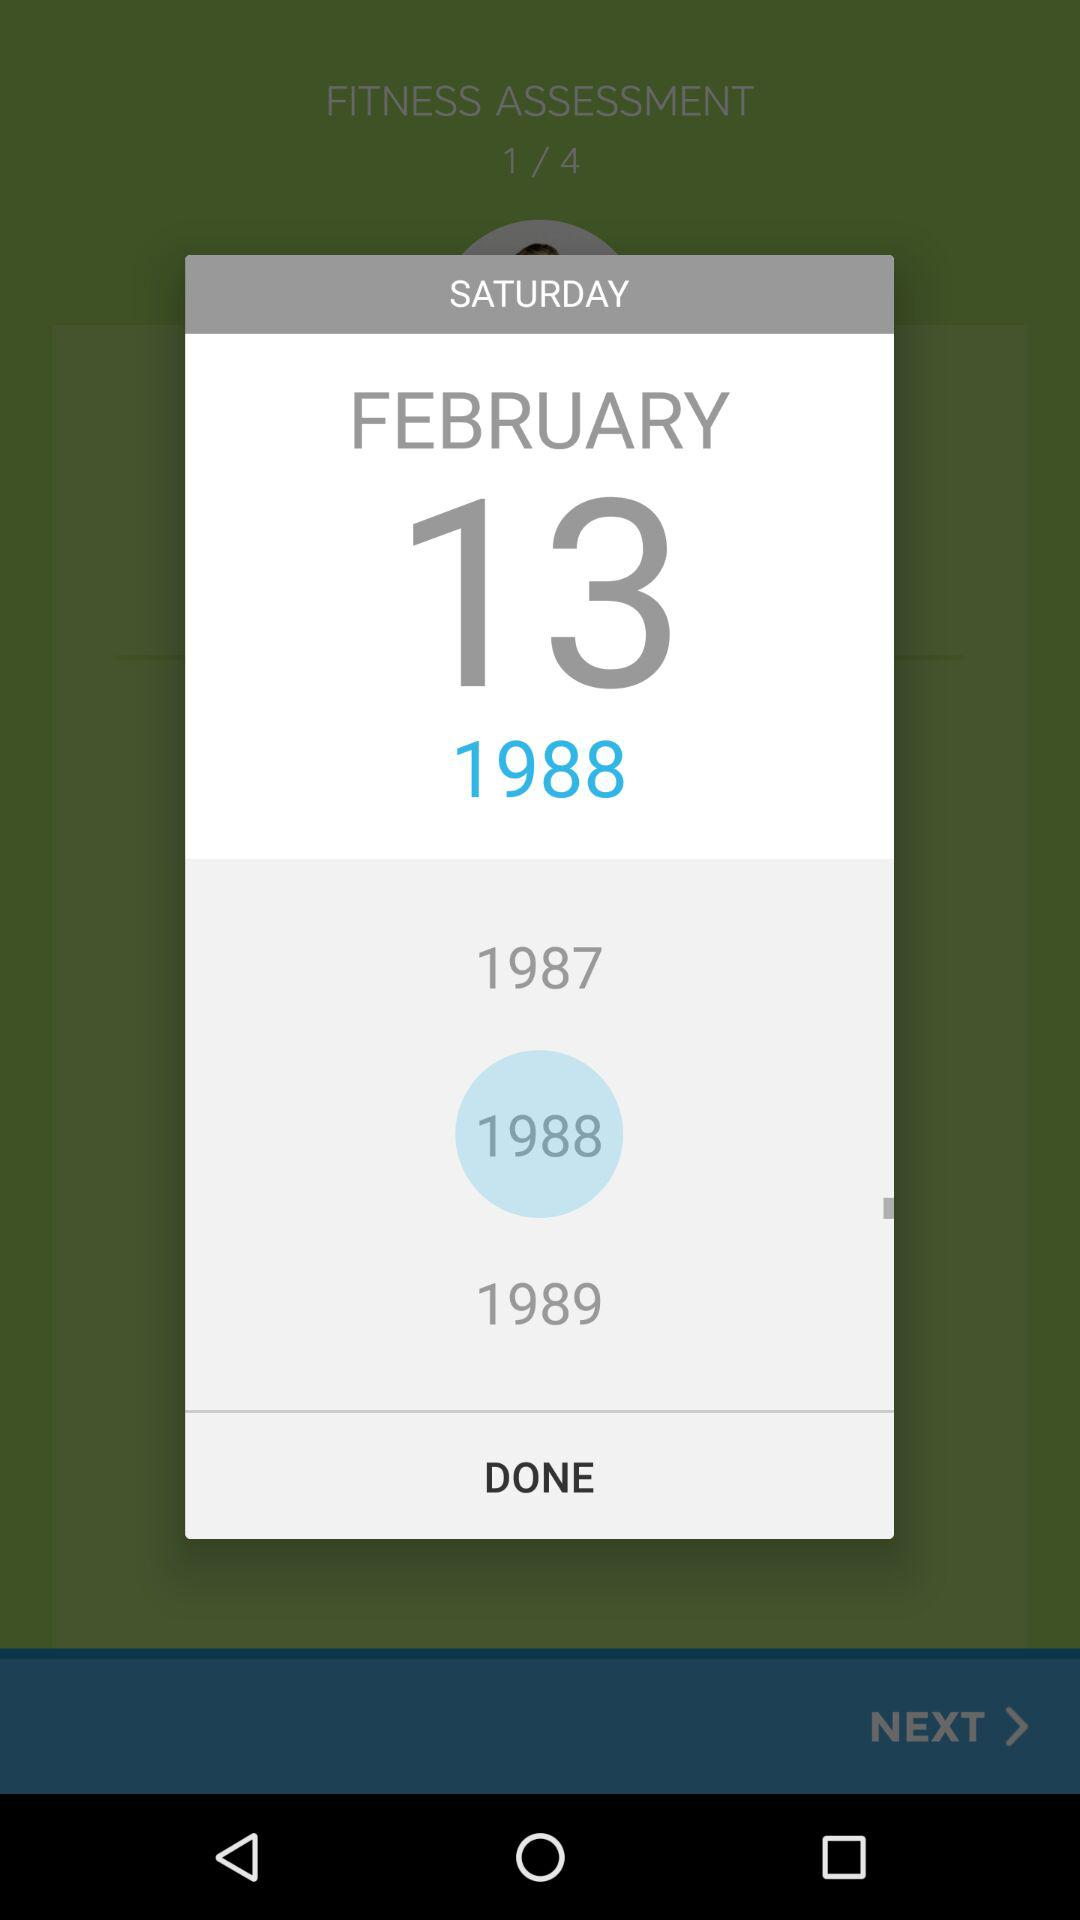What is the selected year? The selected year is 1988. 